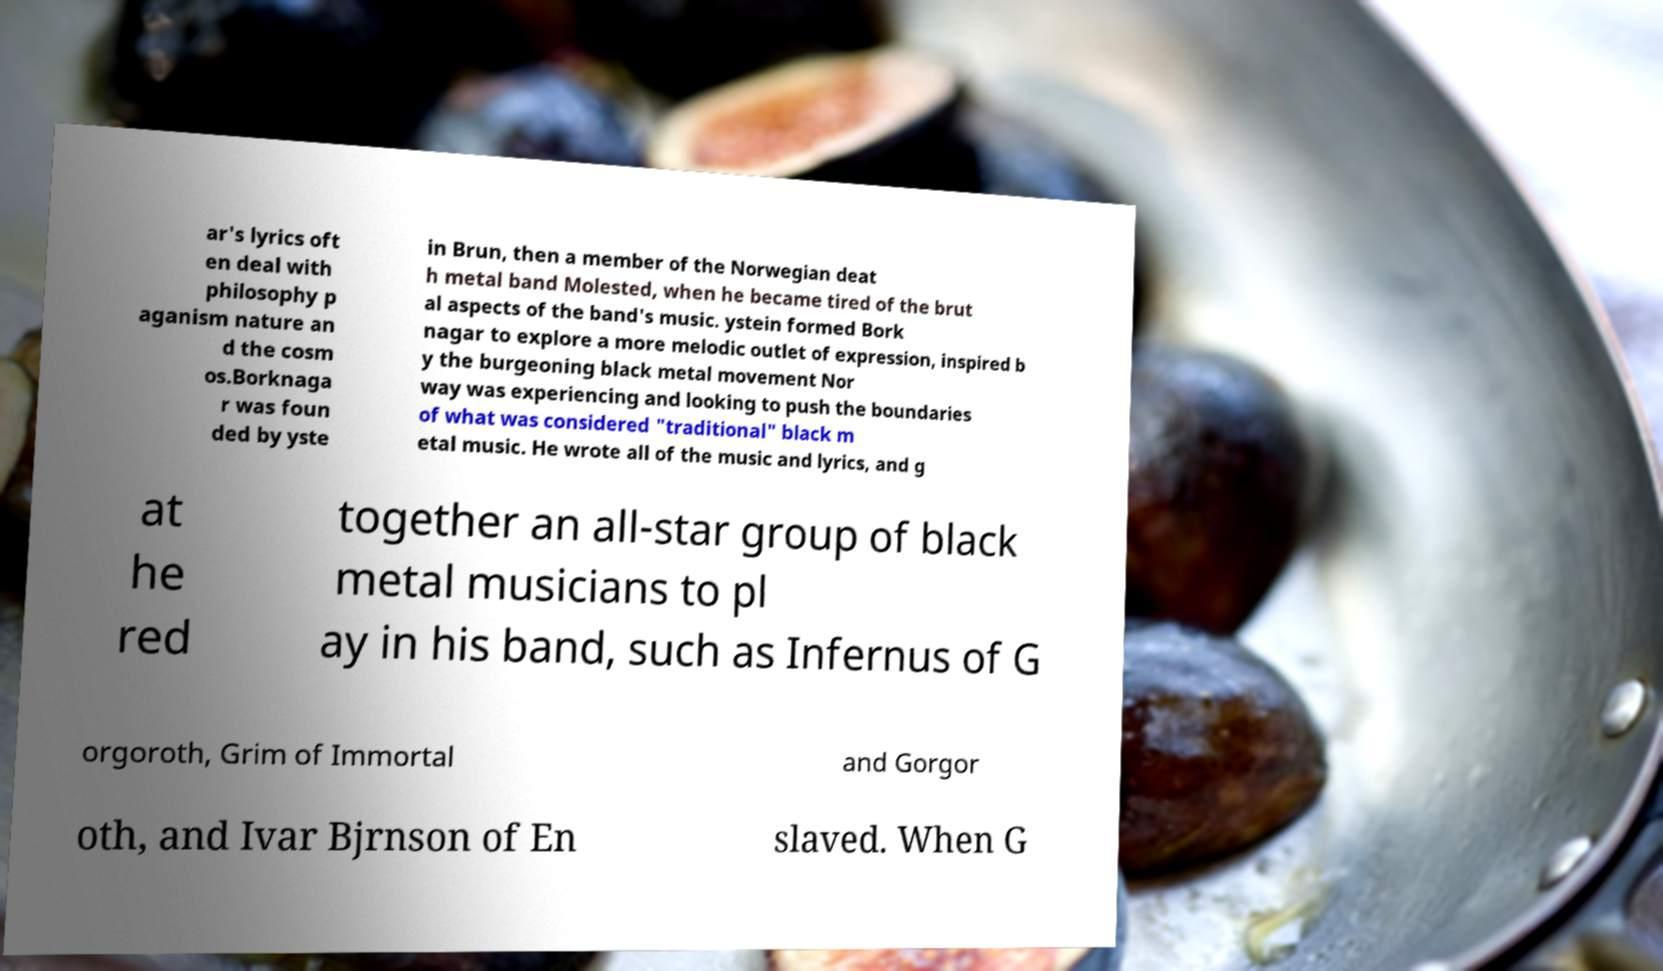Please identify and transcribe the text found in this image. ar's lyrics oft en deal with philosophy p aganism nature an d the cosm os.Borknaga r was foun ded by yste in Brun, then a member of the Norwegian deat h metal band Molested, when he became tired of the brut al aspects of the band's music. ystein formed Bork nagar to explore a more melodic outlet of expression, inspired b y the burgeoning black metal movement Nor way was experiencing and looking to push the boundaries of what was considered "traditional" black m etal music. He wrote all of the music and lyrics, and g at he red together an all-star group of black metal musicians to pl ay in his band, such as Infernus of G orgoroth, Grim of Immortal and Gorgor oth, and Ivar Bjrnson of En slaved. When G 